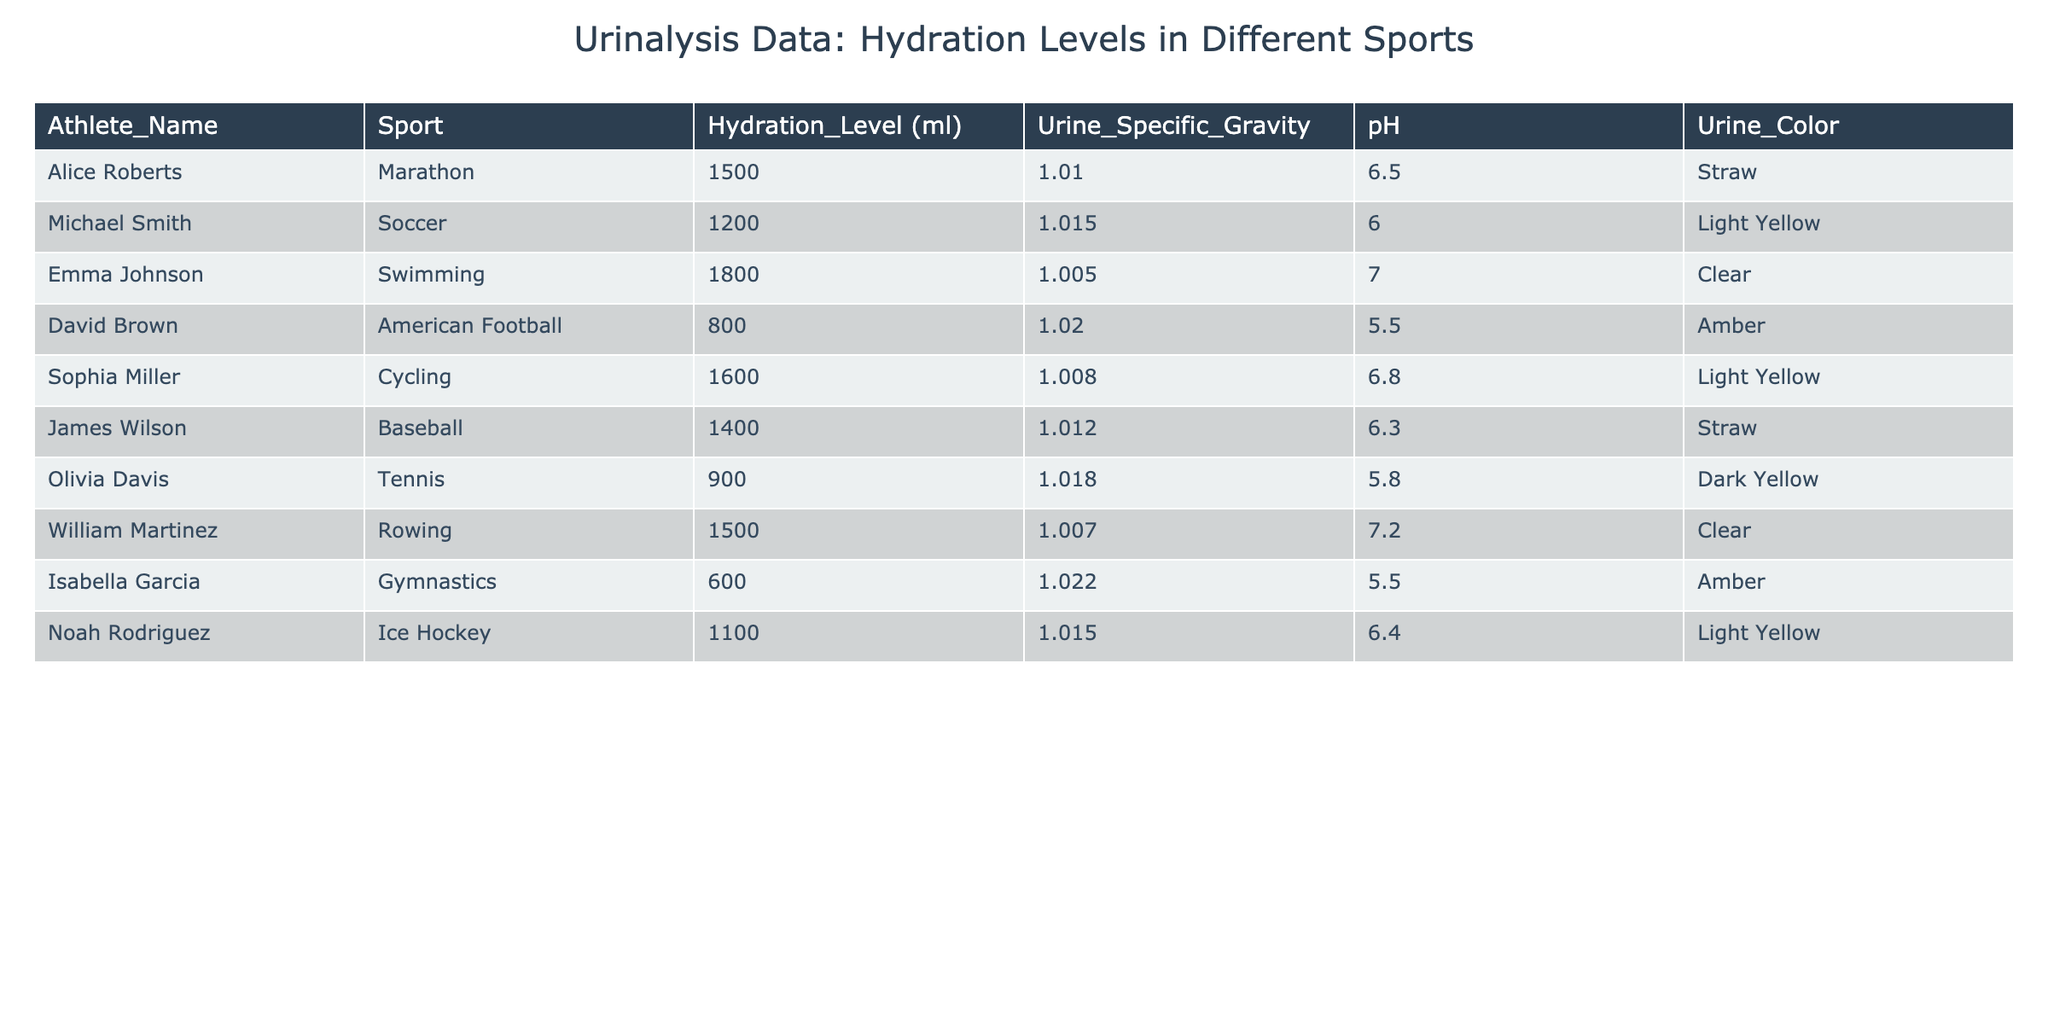What is the hydration level of Emma Johnson? From the table, I can easily locate Emma Johnson's row, and her hydration level is listed as 1800 ml.
Answer: 1800 ml Which sport has the highest urine specific gravity? By reviewing the urine specific gravity values in the table, I see that Sophia Miller (Cycling) has a urine specific gravity of 1.008, but Isabella Garcia (Gymnastics) has a higher value at 1.022. Therefore, the sport with the highest urine specific gravity is Gymnastics.
Answer: Gymnastics Are athletes in team sports generally more hydrated than those in individual sports? Team sports include Soccer and American Football, with hydration levels of 1200 ml and 800 ml, respectively. In comparison, individual sports like Swimming and Cycling have hydration levels of 1800 ml and 1600 ml. The average hydration level for team sports (1000 ml) is less than that for individual sports (1700 ml). Thus, the statement is true.
Answer: Yes What is the average hydration level across all athletes? To calculate the average, I sum all hydration levels: (1500 + 1200 + 1800 + 800 + 1600 + 1400 + 900 + 1500 + 600 + 1100) = 10100 ml. There are 10 athletes, so the average hydration level is 10100 ml / 10 = 1010 ml.
Answer: 1010 ml Which athlete has the lowest pH level, and what sport do they play? By checking the pH values in the table, I find that Isabella Garcia (Gymnastics) has the lowest pH level at 5.5, which equals the urine pH for David Brown (American Football), but Isabella is listed first. Therefore, Isabella Garcia is the athlete with the lowest pH level.
Answer: Isabella Garcia, Gymnastics 